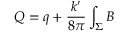Convert formula to latex. <formula><loc_0><loc_0><loc_500><loc_500>Q = q + \frac { k ^ { \prime } } { 8 \pi } \int _ { \Sigma } B</formula> 